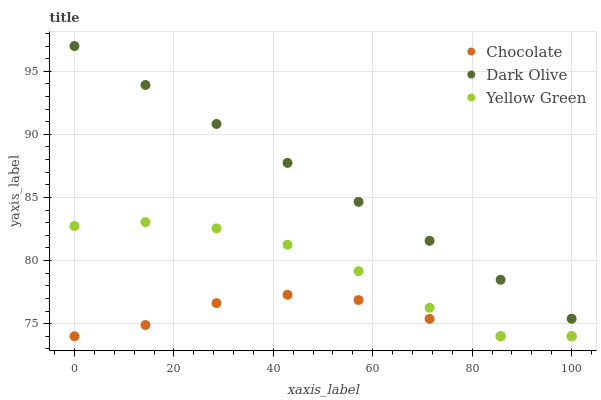Does Chocolate have the minimum area under the curve?
Answer yes or no. Yes. Does Dark Olive have the maximum area under the curve?
Answer yes or no. Yes. Does Yellow Green have the minimum area under the curve?
Answer yes or no. No. Does Yellow Green have the maximum area under the curve?
Answer yes or no. No. Is Dark Olive the smoothest?
Answer yes or no. Yes. Is Yellow Green the roughest?
Answer yes or no. Yes. Is Chocolate the smoothest?
Answer yes or no. No. Is Chocolate the roughest?
Answer yes or no. No. Does Yellow Green have the lowest value?
Answer yes or no. Yes. Does Dark Olive have the highest value?
Answer yes or no. Yes. Does Yellow Green have the highest value?
Answer yes or no. No. Is Yellow Green less than Dark Olive?
Answer yes or no. Yes. Is Dark Olive greater than Yellow Green?
Answer yes or no. Yes. Does Yellow Green intersect Chocolate?
Answer yes or no. Yes. Is Yellow Green less than Chocolate?
Answer yes or no. No. Is Yellow Green greater than Chocolate?
Answer yes or no. No. Does Yellow Green intersect Dark Olive?
Answer yes or no. No. 